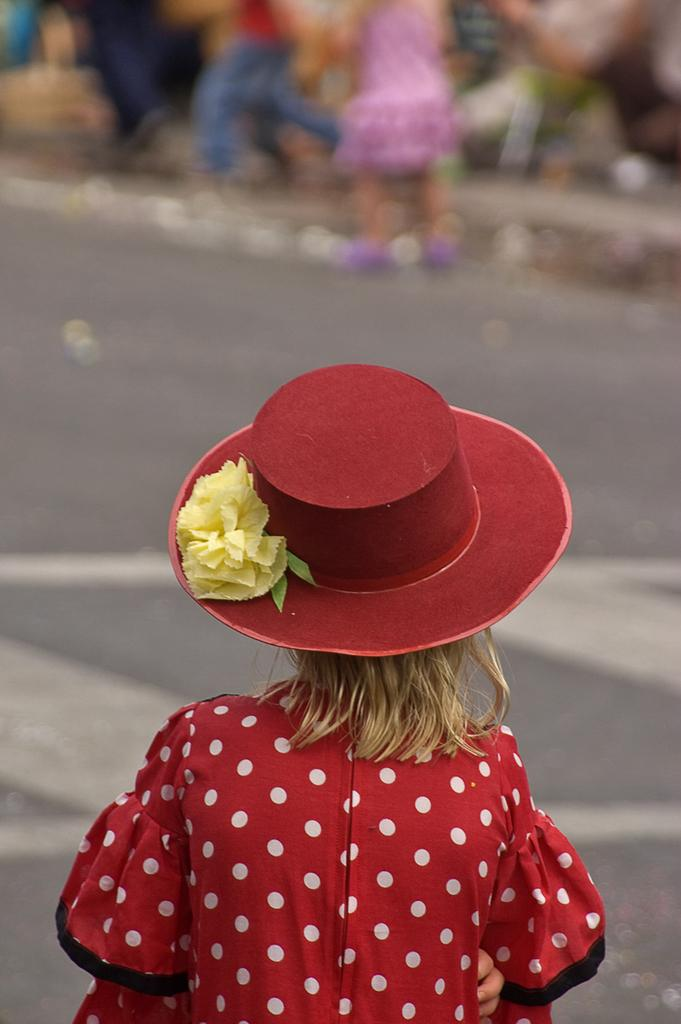What is the main subject of the image? There is a girl standing in the middle of the image. Can you describe the girl's position in the image? The girl is standing in the middle of the image. Are there any other people visible in the image? Yes, there are people standing at the top of the image, but they are blurry. What type of celery is the girl holding in the image? There is no celery present in the image; the girl is not holding any vegetables or objects. 